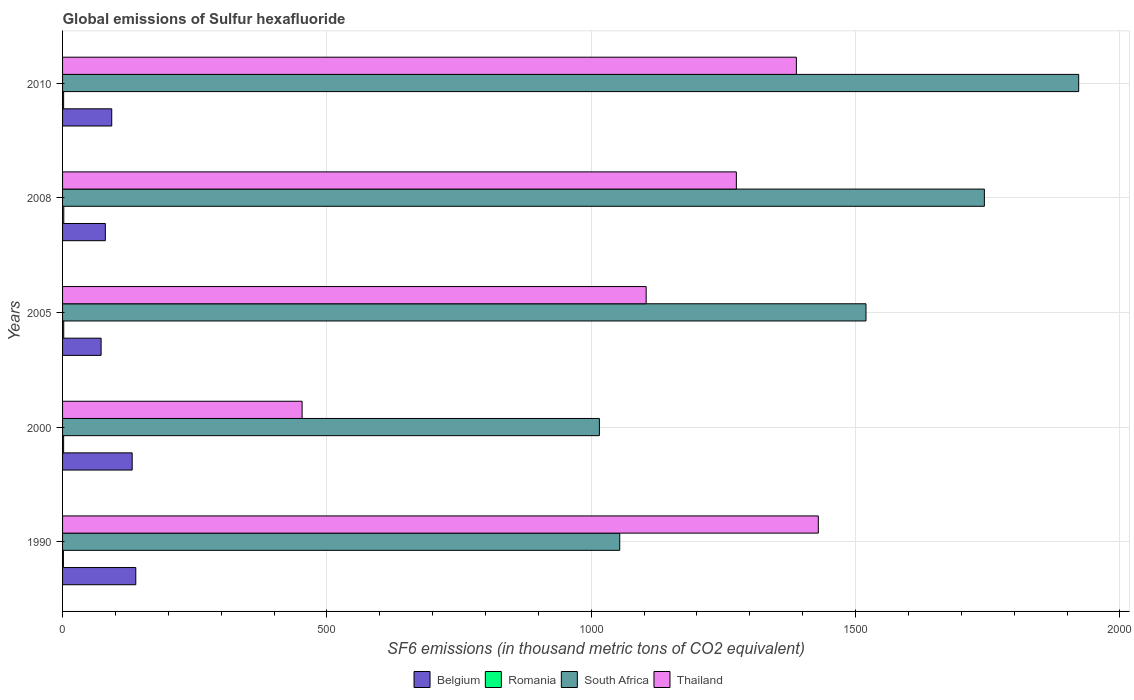How many different coloured bars are there?
Provide a succinct answer. 4. How many groups of bars are there?
Your answer should be very brief. 5. Are the number of bars per tick equal to the number of legend labels?
Provide a short and direct response. Yes. What is the label of the 2nd group of bars from the top?
Your response must be concise. 2008. In how many cases, is the number of bars for a given year not equal to the number of legend labels?
Your answer should be very brief. 0. What is the global emissions of Sulfur hexafluoride in South Africa in 2000?
Your answer should be very brief. 1015.4. Across all years, what is the maximum global emissions of Sulfur hexafluoride in Belgium?
Ensure brevity in your answer.  138.5. Across all years, what is the minimum global emissions of Sulfur hexafluoride in Romania?
Offer a very short reply. 1.6. In which year was the global emissions of Sulfur hexafluoride in Thailand minimum?
Ensure brevity in your answer.  2000. What is the total global emissions of Sulfur hexafluoride in Romania in the graph?
Provide a succinct answer. 10.1. What is the difference between the global emissions of Sulfur hexafluoride in South Africa in 2000 and that in 2005?
Make the answer very short. -504.3. What is the difference between the global emissions of Sulfur hexafluoride in South Africa in 2010 and the global emissions of Sulfur hexafluoride in Belgium in 2008?
Keep it short and to the point. 1841.1. What is the average global emissions of Sulfur hexafluoride in South Africa per year?
Provide a succinct answer. 1450.92. In the year 2008, what is the difference between the global emissions of Sulfur hexafluoride in Romania and global emissions of Sulfur hexafluoride in Thailand?
Keep it short and to the point. -1272.2. What is the ratio of the global emissions of Sulfur hexafluoride in Thailand in 2008 to that in 2010?
Your answer should be compact. 0.92. Is the global emissions of Sulfur hexafluoride in Romania in 1990 less than that in 2008?
Offer a terse response. Yes. Is the difference between the global emissions of Sulfur hexafluoride in Romania in 1990 and 2010 greater than the difference between the global emissions of Sulfur hexafluoride in Thailand in 1990 and 2010?
Provide a succinct answer. No. What is the difference between the highest and the second highest global emissions of Sulfur hexafluoride in South Africa?
Offer a terse response. 178.4. What is the difference between the highest and the lowest global emissions of Sulfur hexafluoride in Belgium?
Offer a terse response. 65.6. What does the 2nd bar from the top in 2000 represents?
Keep it short and to the point. South Africa. What does the 3rd bar from the bottom in 2005 represents?
Offer a very short reply. South Africa. Is it the case that in every year, the sum of the global emissions of Sulfur hexafluoride in Thailand and global emissions of Sulfur hexafluoride in South Africa is greater than the global emissions of Sulfur hexafluoride in Belgium?
Ensure brevity in your answer.  Yes. How many bars are there?
Provide a succinct answer. 20. Are all the bars in the graph horizontal?
Provide a succinct answer. Yes. How many years are there in the graph?
Keep it short and to the point. 5. What is the difference between two consecutive major ticks on the X-axis?
Make the answer very short. 500. Are the values on the major ticks of X-axis written in scientific E-notation?
Provide a succinct answer. No. Does the graph contain any zero values?
Your answer should be compact. No. Where does the legend appear in the graph?
Offer a terse response. Bottom center. What is the title of the graph?
Ensure brevity in your answer.  Global emissions of Sulfur hexafluoride. Does "Antigua and Barbuda" appear as one of the legend labels in the graph?
Offer a terse response. No. What is the label or title of the X-axis?
Offer a terse response. SF6 emissions (in thousand metric tons of CO2 equivalent). What is the label or title of the Y-axis?
Give a very brief answer. Years. What is the SF6 emissions (in thousand metric tons of CO2 equivalent) in Belgium in 1990?
Keep it short and to the point. 138.5. What is the SF6 emissions (in thousand metric tons of CO2 equivalent) of South Africa in 1990?
Provide a succinct answer. 1053.9. What is the SF6 emissions (in thousand metric tons of CO2 equivalent) of Thailand in 1990?
Your answer should be very brief. 1429.5. What is the SF6 emissions (in thousand metric tons of CO2 equivalent) of Belgium in 2000?
Keep it short and to the point. 131.7. What is the SF6 emissions (in thousand metric tons of CO2 equivalent) of Romania in 2000?
Your answer should be very brief. 2. What is the SF6 emissions (in thousand metric tons of CO2 equivalent) in South Africa in 2000?
Your response must be concise. 1015.4. What is the SF6 emissions (in thousand metric tons of CO2 equivalent) of Thailand in 2000?
Keep it short and to the point. 453.1. What is the SF6 emissions (in thousand metric tons of CO2 equivalent) in Belgium in 2005?
Provide a short and direct response. 72.9. What is the SF6 emissions (in thousand metric tons of CO2 equivalent) in Romania in 2005?
Provide a short and direct response. 2.2. What is the SF6 emissions (in thousand metric tons of CO2 equivalent) of South Africa in 2005?
Your answer should be compact. 1519.7. What is the SF6 emissions (in thousand metric tons of CO2 equivalent) in Thailand in 2005?
Offer a very short reply. 1103.9. What is the SF6 emissions (in thousand metric tons of CO2 equivalent) of Belgium in 2008?
Give a very brief answer. 80.9. What is the SF6 emissions (in thousand metric tons of CO2 equivalent) in South Africa in 2008?
Offer a very short reply. 1743.6. What is the SF6 emissions (in thousand metric tons of CO2 equivalent) of Thailand in 2008?
Provide a succinct answer. 1274.5. What is the SF6 emissions (in thousand metric tons of CO2 equivalent) in Belgium in 2010?
Give a very brief answer. 93. What is the SF6 emissions (in thousand metric tons of CO2 equivalent) in South Africa in 2010?
Your answer should be very brief. 1922. What is the SF6 emissions (in thousand metric tons of CO2 equivalent) of Thailand in 2010?
Provide a short and direct response. 1388. Across all years, what is the maximum SF6 emissions (in thousand metric tons of CO2 equivalent) in Belgium?
Make the answer very short. 138.5. Across all years, what is the maximum SF6 emissions (in thousand metric tons of CO2 equivalent) of South Africa?
Your answer should be compact. 1922. Across all years, what is the maximum SF6 emissions (in thousand metric tons of CO2 equivalent) of Thailand?
Make the answer very short. 1429.5. Across all years, what is the minimum SF6 emissions (in thousand metric tons of CO2 equivalent) in Belgium?
Offer a terse response. 72.9. Across all years, what is the minimum SF6 emissions (in thousand metric tons of CO2 equivalent) of Romania?
Your answer should be compact. 1.6. Across all years, what is the minimum SF6 emissions (in thousand metric tons of CO2 equivalent) in South Africa?
Offer a very short reply. 1015.4. Across all years, what is the minimum SF6 emissions (in thousand metric tons of CO2 equivalent) in Thailand?
Your answer should be compact. 453.1. What is the total SF6 emissions (in thousand metric tons of CO2 equivalent) in Belgium in the graph?
Offer a very short reply. 517. What is the total SF6 emissions (in thousand metric tons of CO2 equivalent) of South Africa in the graph?
Make the answer very short. 7254.6. What is the total SF6 emissions (in thousand metric tons of CO2 equivalent) of Thailand in the graph?
Make the answer very short. 5649. What is the difference between the SF6 emissions (in thousand metric tons of CO2 equivalent) in Romania in 1990 and that in 2000?
Keep it short and to the point. -0.4. What is the difference between the SF6 emissions (in thousand metric tons of CO2 equivalent) in South Africa in 1990 and that in 2000?
Your answer should be compact. 38.5. What is the difference between the SF6 emissions (in thousand metric tons of CO2 equivalent) of Thailand in 1990 and that in 2000?
Offer a terse response. 976.4. What is the difference between the SF6 emissions (in thousand metric tons of CO2 equivalent) in Belgium in 1990 and that in 2005?
Offer a terse response. 65.6. What is the difference between the SF6 emissions (in thousand metric tons of CO2 equivalent) in Romania in 1990 and that in 2005?
Give a very brief answer. -0.6. What is the difference between the SF6 emissions (in thousand metric tons of CO2 equivalent) in South Africa in 1990 and that in 2005?
Your response must be concise. -465.8. What is the difference between the SF6 emissions (in thousand metric tons of CO2 equivalent) in Thailand in 1990 and that in 2005?
Ensure brevity in your answer.  325.6. What is the difference between the SF6 emissions (in thousand metric tons of CO2 equivalent) of Belgium in 1990 and that in 2008?
Your answer should be very brief. 57.6. What is the difference between the SF6 emissions (in thousand metric tons of CO2 equivalent) of South Africa in 1990 and that in 2008?
Offer a very short reply. -689.7. What is the difference between the SF6 emissions (in thousand metric tons of CO2 equivalent) in Thailand in 1990 and that in 2008?
Your answer should be compact. 155. What is the difference between the SF6 emissions (in thousand metric tons of CO2 equivalent) in Belgium in 1990 and that in 2010?
Provide a succinct answer. 45.5. What is the difference between the SF6 emissions (in thousand metric tons of CO2 equivalent) in Romania in 1990 and that in 2010?
Keep it short and to the point. -0.4. What is the difference between the SF6 emissions (in thousand metric tons of CO2 equivalent) of South Africa in 1990 and that in 2010?
Offer a terse response. -868.1. What is the difference between the SF6 emissions (in thousand metric tons of CO2 equivalent) of Thailand in 1990 and that in 2010?
Provide a short and direct response. 41.5. What is the difference between the SF6 emissions (in thousand metric tons of CO2 equivalent) of Belgium in 2000 and that in 2005?
Make the answer very short. 58.8. What is the difference between the SF6 emissions (in thousand metric tons of CO2 equivalent) in South Africa in 2000 and that in 2005?
Ensure brevity in your answer.  -504.3. What is the difference between the SF6 emissions (in thousand metric tons of CO2 equivalent) of Thailand in 2000 and that in 2005?
Your answer should be compact. -650.8. What is the difference between the SF6 emissions (in thousand metric tons of CO2 equivalent) of Belgium in 2000 and that in 2008?
Keep it short and to the point. 50.8. What is the difference between the SF6 emissions (in thousand metric tons of CO2 equivalent) in Romania in 2000 and that in 2008?
Give a very brief answer. -0.3. What is the difference between the SF6 emissions (in thousand metric tons of CO2 equivalent) in South Africa in 2000 and that in 2008?
Make the answer very short. -728.2. What is the difference between the SF6 emissions (in thousand metric tons of CO2 equivalent) in Thailand in 2000 and that in 2008?
Offer a terse response. -821.4. What is the difference between the SF6 emissions (in thousand metric tons of CO2 equivalent) in Belgium in 2000 and that in 2010?
Keep it short and to the point. 38.7. What is the difference between the SF6 emissions (in thousand metric tons of CO2 equivalent) of Romania in 2000 and that in 2010?
Give a very brief answer. 0. What is the difference between the SF6 emissions (in thousand metric tons of CO2 equivalent) of South Africa in 2000 and that in 2010?
Keep it short and to the point. -906.6. What is the difference between the SF6 emissions (in thousand metric tons of CO2 equivalent) of Thailand in 2000 and that in 2010?
Ensure brevity in your answer.  -934.9. What is the difference between the SF6 emissions (in thousand metric tons of CO2 equivalent) in South Africa in 2005 and that in 2008?
Give a very brief answer. -223.9. What is the difference between the SF6 emissions (in thousand metric tons of CO2 equivalent) in Thailand in 2005 and that in 2008?
Provide a short and direct response. -170.6. What is the difference between the SF6 emissions (in thousand metric tons of CO2 equivalent) of Belgium in 2005 and that in 2010?
Provide a short and direct response. -20.1. What is the difference between the SF6 emissions (in thousand metric tons of CO2 equivalent) in Romania in 2005 and that in 2010?
Keep it short and to the point. 0.2. What is the difference between the SF6 emissions (in thousand metric tons of CO2 equivalent) of South Africa in 2005 and that in 2010?
Your response must be concise. -402.3. What is the difference between the SF6 emissions (in thousand metric tons of CO2 equivalent) in Thailand in 2005 and that in 2010?
Your answer should be compact. -284.1. What is the difference between the SF6 emissions (in thousand metric tons of CO2 equivalent) in Romania in 2008 and that in 2010?
Provide a short and direct response. 0.3. What is the difference between the SF6 emissions (in thousand metric tons of CO2 equivalent) of South Africa in 2008 and that in 2010?
Offer a very short reply. -178.4. What is the difference between the SF6 emissions (in thousand metric tons of CO2 equivalent) of Thailand in 2008 and that in 2010?
Give a very brief answer. -113.5. What is the difference between the SF6 emissions (in thousand metric tons of CO2 equivalent) of Belgium in 1990 and the SF6 emissions (in thousand metric tons of CO2 equivalent) of Romania in 2000?
Keep it short and to the point. 136.5. What is the difference between the SF6 emissions (in thousand metric tons of CO2 equivalent) of Belgium in 1990 and the SF6 emissions (in thousand metric tons of CO2 equivalent) of South Africa in 2000?
Make the answer very short. -876.9. What is the difference between the SF6 emissions (in thousand metric tons of CO2 equivalent) in Belgium in 1990 and the SF6 emissions (in thousand metric tons of CO2 equivalent) in Thailand in 2000?
Make the answer very short. -314.6. What is the difference between the SF6 emissions (in thousand metric tons of CO2 equivalent) in Romania in 1990 and the SF6 emissions (in thousand metric tons of CO2 equivalent) in South Africa in 2000?
Keep it short and to the point. -1013.8. What is the difference between the SF6 emissions (in thousand metric tons of CO2 equivalent) in Romania in 1990 and the SF6 emissions (in thousand metric tons of CO2 equivalent) in Thailand in 2000?
Provide a short and direct response. -451.5. What is the difference between the SF6 emissions (in thousand metric tons of CO2 equivalent) in South Africa in 1990 and the SF6 emissions (in thousand metric tons of CO2 equivalent) in Thailand in 2000?
Provide a short and direct response. 600.8. What is the difference between the SF6 emissions (in thousand metric tons of CO2 equivalent) of Belgium in 1990 and the SF6 emissions (in thousand metric tons of CO2 equivalent) of Romania in 2005?
Provide a short and direct response. 136.3. What is the difference between the SF6 emissions (in thousand metric tons of CO2 equivalent) of Belgium in 1990 and the SF6 emissions (in thousand metric tons of CO2 equivalent) of South Africa in 2005?
Make the answer very short. -1381.2. What is the difference between the SF6 emissions (in thousand metric tons of CO2 equivalent) in Belgium in 1990 and the SF6 emissions (in thousand metric tons of CO2 equivalent) in Thailand in 2005?
Your answer should be compact. -965.4. What is the difference between the SF6 emissions (in thousand metric tons of CO2 equivalent) in Romania in 1990 and the SF6 emissions (in thousand metric tons of CO2 equivalent) in South Africa in 2005?
Your answer should be compact. -1518.1. What is the difference between the SF6 emissions (in thousand metric tons of CO2 equivalent) in Romania in 1990 and the SF6 emissions (in thousand metric tons of CO2 equivalent) in Thailand in 2005?
Offer a terse response. -1102.3. What is the difference between the SF6 emissions (in thousand metric tons of CO2 equivalent) in South Africa in 1990 and the SF6 emissions (in thousand metric tons of CO2 equivalent) in Thailand in 2005?
Make the answer very short. -50. What is the difference between the SF6 emissions (in thousand metric tons of CO2 equivalent) in Belgium in 1990 and the SF6 emissions (in thousand metric tons of CO2 equivalent) in Romania in 2008?
Your answer should be very brief. 136.2. What is the difference between the SF6 emissions (in thousand metric tons of CO2 equivalent) of Belgium in 1990 and the SF6 emissions (in thousand metric tons of CO2 equivalent) of South Africa in 2008?
Give a very brief answer. -1605.1. What is the difference between the SF6 emissions (in thousand metric tons of CO2 equivalent) in Belgium in 1990 and the SF6 emissions (in thousand metric tons of CO2 equivalent) in Thailand in 2008?
Offer a terse response. -1136. What is the difference between the SF6 emissions (in thousand metric tons of CO2 equivalent) of Romania in 1990 and the SF6 emissions (in thousand metric tons of CO2 equivalent) of South Africa in 2008?
Offer a terse response. -1742. What is the difference between the SF6 emissions (in thousand metric tons of CO2 equivalent) of Romania in 1990 and the SF6 emissions (in thousand metric tons of CO2 equivalent) of Thailand in 2008?
Give a very brief answer. -1272.9. What is the difference between the SF6 emissions (in thousand metric tons of CO2 equivalent) of South Africa in 1990 and the SF6 emissions (in thousand metric tons of CO2 equivalent) of Thailand in 2008?
Your answer should be compact. -220.6. What is the difference between the SF6 emissions (in thousand metric tons of CO2 equivalent) of Belgium in 1990 and the SF6 emissions (in thousand metric tons of CO2 equivalent) of Romania in 2010?
Make the answer very short. 136.5. What is the difference between the SF6 emissions (in thousand metric tons of CO2 equivalent) of Belgium in 1990 and the SF6 emissions (in thousand metric tons of CO2 equivalent) of South Africa in 2010?
Your response must be concise. -1783.5. What is the difference between the SF6 emissions (in thousand metric tons of CO2 equivalent) of Belgium in 1990 and the SF6 emissions (in thousand metric tons of CO2 equivalent) of Thailand in 2010?
Your answer should be very brief. -1249.5. What is the difference between the SF6 emissions (in thousand metric tons of CO2 equivalent) of Romania in 1990 and the SF6 emissions (in thousand metric tons of CO2 equivalent) of South Africa in 2010?
Keep it short and to the point. -1920.4. What is the difference between the SF6 emissions (in thousand metric tons of CO2 equivalent) in Romania in 1990 and the SF6 emissions (in thousand metric tons of CO2 equivalent) in Thailand in 2010?
Offer a very short reply. -1386.4. What is the difference between the SF6 emissions (in thousand metric tons of CO2 equivalent) of South Africa in 1990 and the SF6 emissions (in thousand metric tons of CO2 equivalent) of Thailand in 2010?
Give a very brief answer. -334.1. What is the difference between the SF6 emissions (in thousand metric tons of CO2 equivalent) of Belgium in 2000 and the SF6 emissions (in thousand metric tons of CO2 equivalent) of Romania in 2005?
Your answer should be compact. 129.5. What is the difference between the SF6 emissions (in thousand metric tons of CO2 equivalent) in Belgium in 2000 and the SF6 emissions (in thousand metric tons of CO2 equivalent) in South Africa in 2005?
Ensure brevity in your answer.  -1388. What is the difference between the SF6 emissions (in thousand metric tons of CO2 equivalent) in Belgium in 2000 and the SF6 emissions (in thousand metric tons of CO2 equivalent) in Thailand in 2005?
Your answer should be very brief. -972.2. What is the difference between the SF6 emissions (in thousand metric tons of CO2 equivalent) of Romania in 2000 and the SF6 emissions (in thousand metric tons of CO2 equivalent) of South Africa in 2005?
Offer a terse response. -1517.7. What is the difference between the SF6 emissions (in thousand metric tons of CO2 equivalent) of Romania in 2000 and the SF6 emissions (in thousand metric tons of CO2 equivalent) of Thailand in 2005?
Give a very brief answer. -1101.9. What is the difference between the SF6 emissions (in thousand metric tons of CO2 equivalent) of South Africa in 2000 and the SF6 emissions (in thousand metric tons of CO2 equivalent) of Thailand in 2005?
Your answer should be very brief. -88.5. What is the difference between the SF6 emissions (in thousand metric tons of CO2 equivalent) of Belgium in 2000 and the SF6 emissions (in thousand metric tons of CO2 equivalent) of Romania in 2008?
Offer a very short reply. 129.4. What is the difference between the SF6 emissions (in thousand metric tons of CO2 equivalent) of Belgium in 2000 and the SF6 emissions (in thousand metric tons of CO2 equivalent) of South Africa in 2008?
Make the answer very short. -1611.9. What is the difference between the SF6 emissions (in thousand metric tons of CO2 equivalent) in Belgium in 2000 and the SF6 emissions (in thousand metric tons of CO2 equivalent) in Thailand in 2008?
Your response must be concise. -1142.8. What is the difference between the SF6 emissions (in thousand metric tons of CO2 equivalent) of Romania in 2000 and the SF6 emissions (in thousand metric tons of CO2 equivalent) of South Africa in 2008?
Offer a very short reply. -1741.6. What is the difference between the SF6 emissions (in thousand metric tons of CO2 equivalent) of Romania in 2000 and the SF6 emissions (in thousand metric tons of CO2 equivalent) of Thailand in 2008?
Your response must be concise. -1272.5. What is the difference between the SF6 emissions (in thousand metric tons of CO2 equivalent) of South Africa in 2000 and the SF6 emissions (in thousand metric tons of CO2 equivalent) of Thailand in 2008?
Your response must be concise. -259.1. What is the difference between the SF6 emissions (in thousand metric tons of CO2 equivalent) in Belgium in 2000 and the SF6 emissions (in thousand metric tons of CO2 equivalent) in Romania in 2010?
Offer a very short reply. 129.7. What is the difference between the SF6 emissions (in thousand metric tons of CO2 equivalent) of Belgium in 2000 and the SF6 emissions (in thousand metric tons of CO2 equivalent) of South Africa in 2010?
Your answer should be compact. -1790.3. What is the difference between the SF6 emissions (in thousand metric tons of CO2 equivalent) of Belgium in 2000 and the SF6 emissions (in thousand metric tons of CO2 equivalent) of Thailand in 2010?
Your answer should be compact. -1256.3. What is the difference between the SF6 emissions (in thousand metric tons of CO2 equivalent) in Romania in 2000 and the SF6 emissions (in thousand metric tons of CO2 equivalent) in South Africa in 2010?
Keep it short and to the point. -1920. What is the difference between the SF6 emissions (in thousand metric tons of CO2 equivalent) in Romania in 2000 and the SF6 emissions (in thousand metric tons of CO2 equivalent) in Thailand in 2010?
Your answer should be compact. -1386. What is the difference between the SF6 emissions (in thousand metric tons of CO2 equivalent) of South Africa in 2000 and the SF6 emissions (in thousand metric tons of CO2 equivalent) of Thailand in 2010?
Ensure brevity in your answer.  -372.6. What is the difference between the SF6 emissions (in thousand metric tons of CO2 equivalent) in Belgium in 2005 and the SF6 emissions (in thousand metric tons of CO2 equivalent) in Romania in 2008?
Your answer should be very brief. 70.6. What is the difference between the SF6 emissions (in thousand metric tons of CO2 equivalent) in Belgium in 2005 and the SF6 emissions (in thousand metric tons of CO2 equivalent) in South Africa in 2008?
Your answer should be very brief. -1670.7. What is the difference between the SF6 emissions (in thousand metric tons of CO2 equivalent) in Belgium in 2005 and the SF6 emissions (in thousand metric tons of CO2 equivalent) in Thailand in 2008?
Offer a very short reply. -1201.6. What is the difference between the SF6 emissions (in thousand metric tons of CO2 equivalent) of Romania in 2005 and the SF6 emissions (in thousand metric tons of CO2 equivalent) of South Africa in 2008?
Offer a very short reply. -1741.4. What is the difference between the SF6 emissions (in thousand metric tons of CO2 equivalent) in Romania in 2005 and the SF6 emissions (in thousand metric tons of CO2 equivalent) in Thailand in 2008?
Make the answer very short. -1272.3. What is the difference between the SF6 emissions (in thousand metric tons of CO2 equivalent) in South Africa in 2005 and the SF6 emissions (in thousand metric tons of CO2 equivalent) in Thailand in 2008?
Your answer should be very brief. 245.2. What is the difference between the SF6 emissions (in thousand metric tons of CO2 equivalent) of Belgium in 2005 and the SF6 emissions (in thousand metric tons of CO2 equivalent) of Romania in 2010?
Offer a terse response. 70.9. What is the difference between the SF6 emissions (in thousand metric tons of CO2 equivalent) in Belgium in 2005 and the SF6 emissions (in thousand metric tons of CO2 equivalent) in South Africa in 2010?
Keep it short and to the point. -1849.1. What is the difference between the SF6 emissions (in thousand metric tons of CO2 equivalent) in Belgium in 2005 and the SF6 emissions (in thousand metric tons of CO2 equivalent) in Thailand in 2010?
Offer a terse response. -1315.1. What is the difference between the SF6 emissions (in thousand metric tons of CO2 equivalent) in Romania in 2005 and the SF6 emissions (in thousand metric tons of CO2 equivalent) in South Africa in 2010?
Provide a succinct answer. -1919.8. What is the difference between the SF6 emissions (in thousand metric tons of CO2 equivalent) in Romania in 2005 and the SF6 emissions (in thousand metric tons of CO2 equivalent) in Thailand in 2010?
Your answer should be compact. -1385.8. What is the difference between the SF6 emissions (in thousand metric tons of CO2 equivalent) of South Africa in 2005 and the SF6 emissions (in thousand metric tons of CO2 equivalent) of Thailand in 2010?
Your response must be concise. 131.7. What is the difference between the SF6 emissions (in thousand metric tons of CO2 equivalent) in Belgium in 2008 and the SF6 emissions (in thousand metric tons of CO2 equivalent) in Romania in 2010?
Make the answer very short. 78.9. What is the difference between the SF6 emissions (in thousand metric tons of CO2 equivalent) of Belgium in 2008 and the SF6 emissions (in thousand metric tons of CO2 equivalent) of South Africa in 2010?
Offer a terse response. -1841.1. What is the difference between the SF6 emissions (in thousand metric tons of CO2 equivalent) of Belgium in 2008 and the SF6 emissions (in thousand metric tons of CO2 equivalent) of Thailand in 2010?
Provide a short and direct response. -1307.1. What is the difference between the SF6 emissions (in thousand metric tons of CO2 equivalent) of Romania in 2008 and the SF6 emissions (in thousand metric tons of CO2 equivalent) of South Africa in 2010?
Offer a terse response. -1919.7. What is the difference between the SF6 emissions (in thousand metric tons of CO2 equivalent) of Romania in 2008 and the SF6 emissions (in thousand metric tons of CO2 equivalent) of Thailand in 2010?
Ensure brevity in your answer.  -1385.7. What is the difference between the SF6 emissions (in thousand metric tons of CO2 equivalent) in South Africa in 2008 and the SF6 emissions (in thousand metric tons of CO2 equivalent) in Thailand in 2010?
Your answer should be compact. 355.6. What is the average SF6 emissions (in thousand metric tons of CO2 equivalent) in Belgium per year?
Offer a very short reply. 103.4. What is the average SF6 emissions (in thousand metric tons of CO2 equivalent) in Romania per year?
Your answer should be very brief. 2.02. What is the average SF6 emissions (in thousand metric tons of CO2 equivalent) of South Africa per year?
Ensure brevity in your answer.  1450.92. What is the average SF6 emissions (in thousand metric tons of CO2 equivalent) of Thailand per year?
Give a very brief answer. 1129.8. In the year 1990, what is the difference between the SF6 emissions (in thousand metric tons of CO2 equivalent) of Belgium and SF6 emissions (in thousand metric tons of CO2 equivalent) of Romania?
Ensure brevity in your answer.  136.9. In the year 1990, what is the difference between the SF6 emissions (in thousand metric tons of CO2 equivalent) of Belgium and SF6 emissions (in thousand metric tons of CO2 equivalent) of South Africa?
Keep it short and to the point. -915.4. In the year 1990, what is the difference between the SF6 emissions (in thousand metric tons of CO2 equivalent) in Belgium and SF6 emissions (in thousand metric tons of CO2 equivalent) in Thailand?
Provide a succinct answer. -1291. In the year 1990, what is the difference between the SF6 emissions (in thousand metric tons of CO2 equivalent) of Romania and SF6 emissions (in thousand metric tons of CO2 equivalent) of South Africa?
Ensure brevity in your answer.  -1052.3. In the year 1990, what is the difference between the SF6 emissions (in thousand metric tons of CO2 equivalent) in Romania and SF6 emissions (in thousand metric tons of CO2 equivalent) in Thailand?
Make the answer very short. -1427.9. In the year 1990, what is the difference between the SF6 emissions (in thousand metric tons of CO2 equivalent) of South Africa and SF6 emissions (in thousand metric tons of CO2 equivalent) of Thailand?
Provide a succinct answer. -375.6. In the year 2000, what is the difference between the SF6 emissions (in thousand metric tons of CO2 equivalent) in Belgium and SF6 emissions (in thousand metric tons of CO2 equivalent) in Romania?
Provide a short and direct response. 129.7. In the year 2000, what is the difference between the SF6 emissions (in thousand metric tons of CO2 equivalent) of Belgium and SF6 emissions (in thousand metric tons of CO2 equivalent) of South Africa?
Give a very brief answer. -883.7. In the year 2000, what is the difference between the SF6 emissions (in thousand metric tons of CO2 equivalent) in Belgium and SF6 emissions (in thousand metric tons of CO2 equivalent) in Thailand?
Your answer should be very brief. -321.4. In the year 2000, what is the difference between the SF6 emissions (in thousand metric tons of CO2 equivalent) in Romania and SF6 emissions (in thousand metric tons of CO2 equivalent) in South Africa?
Keep it short and to the point. -1013.4. In the year 2000, what is the difference between the SF6 emissions (in thousand metric tons of CO2 equivalent) in Romania and SF6 emissions (in thousand metric tons of CO2 equivalent) in Thailand?
Offer a very short reply. -451.1. In the year 2000, what is the difference between the SF6 emissions (in thousand metric tons of CO2 equivalent) of South Africa and SF6 emissions (in thousand metric tons of CO2 equivalent) of Thailand?
Your answer should be compact. 562.3. In the year 2005, what is the difference between the SF6 emissions (in thousand metric tons of CO2 equivalent) in Belgium and SF6 emissions (in thousand metric tons of CO2 equivalent) in Romania?
Keep it short and to the point. 70.7. In the year 2005, what is the difference between the SF6 emissions (in thousand metric tons of CO2 equivalent) of Belgium and SF6 emissions (in thousand metric tons of CO2 equivalent) of South Africa?
Your answer should be very brief. -1446.8. In the year 2005, what is the difference between the SF6 emissions (in thousand metric tons of CO2 equivalent) of Belgium and SF6 emissions (in thousand metric tons of CO2 equivalent) of Thailand?
Ensure brevity in your answer.  -1031. In the year 2005, what is the difference between the SF6 emissions (in thousand metric tons of CO2 equivalent) of Romania and SF6 emissions (in thousand metric tons of CO2 equivalent) of South Africa?
Give a very brief answer. -1517.5. In the year 2005, what is the difference between the SF6 emissions (in thousand metric tons of CO2 equivalent) of Romania and SF6 emissions (in thousand metric tons of CO2 equivalent) of Thailand?
Give a very brief answer. -1101.7. In the year 2005, what is the difference between the SF6 emissions (in thousand metric tons of CO2 equivalent) in South Africa and SF6 emissions (in thousand metric tons of CO2 equivalent) in Thailand?
Offer a terse response. 415.8. In the year 2008, what is the difference between the SF6 emissions (in thousand metric tons of CO2 equivalent) in Belgium and SF6 emissions (in thousand metric tons of CO2 equivalent) in Romania?
Provide a short and direct response. 78.6. In the year 2008, what is the difference between the SF6 emissions (in thousand metric tons of CO2 equivalent) in Belgium and SF6 emissions (in thousand metric tons of CO2 equivalent) in South Africa?
Provide a short and direct response. -1662.7. In the year 2008, what is the difference between the SF6 emissions (in thousand metric tons of CO2 equivalent) in Belgium and SF6 emissions (in thousand metric tons of CO2 equivalent) in Thailand?
Your response must be concise. -1193.6. In the year 2008, what is the difference between the SF6 emissions (in thousand metric tons of CO2 equivalent) in Romania and SF6 emissions (in thousand metric tons of CO2 equivalent) in South Africa?
Give a very brief answer. -1741.3. In the year 2008, what is the difference between the SF6 emissions (in thousand metric tons of CO2 equivalent) of Romania and SF6 emissions (in thousand metric tons of CO2 equivalent) of Thailand?
Offer a terse response. -1272.2. In the year 2008, what is the difference between the SF6 emissions (in thousand metric tons of CO2 equivalent) of South Africa and SF6 emissions (in thousand metric tons of CO2 equivalent) of Thailand?
Make the answer very short. 469.1. In the year 2010, what is the difference between the SF6 emissions (in thousand metric tons of CO2 equivalent) in Belgium and SF6 emissions (in thousand metric tons of CO2 equivalent) in Romania?
Offer a very short reply. 91. In the year 2010, what is the difference between the SF6 emissions (in thousand metric tons of CO2 equivalent) in Belgium and SF6 emissions (in thousand metric tons of CO2 equivalent) in South Africa?
Ensure brevity in your answer.  -1829. In the year 2010, what is the difference between the SF6 emissions (in thousand metric tons of CO2 equivalent) of Belgium and SF6 emissions (in thousand metric tons of CO2 equivalent) of Thailand?
Keep it short and to the point. -1295. In the year 2010, what is the difference between the SF6 emissions (in thousand metric tons of CO2 equivalent) in Romania and SF6 emissions (in thousand metric tons of CO2 equivalent) in South Africa?
Offer a very short reply. -1920. In the year 2010, what is the difference between the SF6 emissions (in thousand metric tons of CO2 equivalent) in Romania and SF6 emissions (in thousand metric tons of CO2 equivalent) in Thailand?
Your response must be concise. -1386. In the year 2010, what is the difference between the SF6 emissions (in thousand metric tons of CO2 equivalent) in South Africa and SF6 emissions (in thousand metric tons of CO2 equivalent) in Thailand?
Your answer should be compact. 534. What is the ratio of the SF6 emissions (in thousand metric tons of CO2 equivalent) in Belgium in 1990 to that in 2000?
Provide a short and direct response. 1.05. What is the ratio of the SF6 emissions (in thousand metric tons of CO2 equivalent) of Romania in 1990 to that in 2000?
Make the answer very short. 0.8. What is the ratio of the SF6 emissions (in thousand metric tons of CO2 equivalent) in South Africa in 1990 to that in 2000?
Your answer should be compact. 1.04. What is the ratio of the SF6 emissions (in thousand metric tons of CO2 equivalent) of Thailand in 1990 to that in 2000?
Keep it short and to the point. 3.15. What is the ratio of the SF6 emissions (in thousand metric tons of CO2 equivalent) of Belgium in 1990 to that in 2005?
Ensure brevity in your answer.  1.9. What is the ratio of the SF6 emissions (in thousand metric tons of CO2 equivalent) in Romania in 1990 to that in 2005?
Give a very brief answer. 0.73. What is the ratio of the SF6 emissions (in thousand metric tons of CO2 equivalent) in South Africa in 1990 to that in 2005?
Provide a succinct answer. 0.69. What is the ratio of the SF6 emissions (in thousand metric tons of CO2 equivalent) in Thailand in 1990 to that in 2005?
Your response must be concise. 1.29. What is the ratio of the SF6 emissions (in thousand metric tons of CO2 equivalent) in Belgium in 1990 to that in 2008?
Give a very brief answer. 1.71. What is the ratio of the SF6 emissions (in thousand metric tons of CO2 equivalent) of Romania in 1990 to that in 2008?
Offer a terse response. 0.7. What is the ratio of the SF6 emissions (in thousand metric tons of CO2 equivalent) of South Africa in 1990 to that in 2008?
Keep it short and to the point. 0.6. What is the ratio of the SF6 emissions (in thousand metric tons of CO2 equivalent) of Thailand in 1990 to that in 2008?
Keep it short and to the point. 1.12. What is the ratio of the SF6 emissions (in thousand metric tons of CO2 equivalent) in Belgium in 1990 to that in 2010?
Provide a succinct answer. 1.49. What is the ratio of the SF6 emissions (in thousand metric tons of CO2 equivalent) of South Africa in 1990 to that in 2010?
Offer a very short reply. 0.55. What is the ratio of the SF6 emissions (in thousand metric tons of CO2 equivalent) in Thailand in 1990 to that in 2010?
Your response must be concise. 1.03. What is the ratio of the SF6 emissions (in thousand metric tons of CO2 equivalent) in Belgium in 2000 to that in 2005?
Your response must be concise. 1.81. What is the ratio of the SF6 emissions (in thousand metric tons of CO2 equivalent) of Romania in 2000 to that in 2005?
Give a very brief answer. 0.91. What is the ratio of the SF6 emissions (in thousand metric tons of CO2 equivalent) of South Africa in 2000 to that in 2005?
Make the answer very short. 0.67. What is the ratio of the SF6 emissions (in thousand metric tons of CO2 equivalent) of Thailand in 2000 to that in 2005?
Ensure brevity in your answer.  0.41. What is the ratio of the SF6 emissions (in thousand metric tons of CO2 equivalent) in Belgium in 2000 to that in 2008?
Offer a terse response. 1.63. What is the ratio of the SF6 emissions (in thousand metric tons of CO2 equivalent) in Romania in 2000 to that in 2008?
Provide a short and direct response. 0.87. What is the ratio of the SF6 emissions (in thousand metric tons of CO2 equivalent) of South Africa in 2000 to that in 2008?
Ensure brevity in your answer.  0.58. What is the ratio of the SF6 emissions (in thousand metric tons of CO2 equivalent) of Thailand in 2000 to that in 2008?
Your answer should be compact. 0.36. What is the ratio of the SF6 emissions (in thousand metric tons of CO2 equivalent) in Belgium in 2000 to that in 2010?
Offer a terse response. 1.42. What is the ratio of the SF6 emissions (in thousand metric tons of CO2 equivalent) in South Africa in 2000 to that in 2010?
Your answer should be very brief. 0.53. What is the ratio of the SF6 emissions (in thousand metric tons of CO2 equivalent) of Thailand in 2000 to that in 2010?
Ensure brevity in your answer.  0.33. What is the ratio of the SF6 emissions (in thousand metric tons of CO2 equivalent) of Belgium in 2005 to that in 2008?
Offer a very short reply. 0.9. What is the ratio of the SF6 emissions (in thousand metric tons of CO2 equivalent) in Romania in 2005 to that in 2008?
Keep it short and to the point. 0.96. What is the ratio of the SF6 emissions (in thousand metric tons of CO2 equivalent) of South Africa in 2005 to that in 2008?
Provide a succinct answer. 0.87. What is the ratio of the SF6 emissions (in thousand metric tons of CO2 equivalent) in Thailand in 2005 to that in 2008?
Provide a short and direct response. 0.87. What is the ratio of the SF6 emissions (in thousand metric tons of CO2 equivalent) of Belgium in 2005 to that in 2010?
Offer a very short reply. 0.78. What is the ratio of the SF6 emissions (in thousand metric tons of CO2 equivalent) in Romania in 2005 to that in 2010?
Offer a very short reply. 1.1. What is the ratio of the SF6 emissions (in thousand metric tons of CO2 equivalent) in South Africa in 2005 to that in 2010?
Your answer should be compact. 0.79. What is the ratio of the SF6 emissions (in thousand metric tons of CO2 equivalent) of Thailand in 2005 to that in 2010?
Your answer should be very brief. 0.8. What is the ratio of the SF6 emissions (in thousand metric tons of CO2 equivalent) of Belgium in 2008 to that in 2010?
Offer a terse response. 0.87. What is the ratio of the SF6 emissions (in thousand metric tons of CO2 equivalent) in Romania in 2008 to that in 2010?
Ensure brevity in your answer.  1.15. What is the ratio of the SF6 emissions (in thousand metric tons of CO2 equivalent) of South Africa in 2008 to that in 2010?
Offer a terse response. 0.91. What is the ratio of the SF6 emissions (in thousand metric tons of CO2 equivalent) of Thailand in 2008 to that in 2010?
Keep it short and to the point. 0.92. What is the difference between the highest and the second highest SF6 emissions (in thousand metric tons of CO2 equivalent) of South Africa?
Provide a short and direct response. 178.4. What is the difference between the highest and the second highest SF6 emissions (in thousand metric tons of CO2 equivalent) in Thailand?
Provide a short and direct response. 41.5. What is the difference between the highest and the lowest SF6 emissions (in thousand metric tons of CO2 equivalent) of Belgium?
Your answer should be very brief. 65.6. What is the difference between the highest and the lowest SF6 emissions (in thousand metric tons of CO2 equivalent) of Romania?
Provide a succinct answer. 0.7. What is the difference between the highest and the lowest SF6 emissions (in thousand metric tons of CO2 equivalent) of South Africa?
Make the answer very short. 906.6. What is the difference between the highest and the lowest SF6 emissions (in thousand metric tons of CO2 equivalent) of Thailand?
Keep it short and to the point. 976.4. 